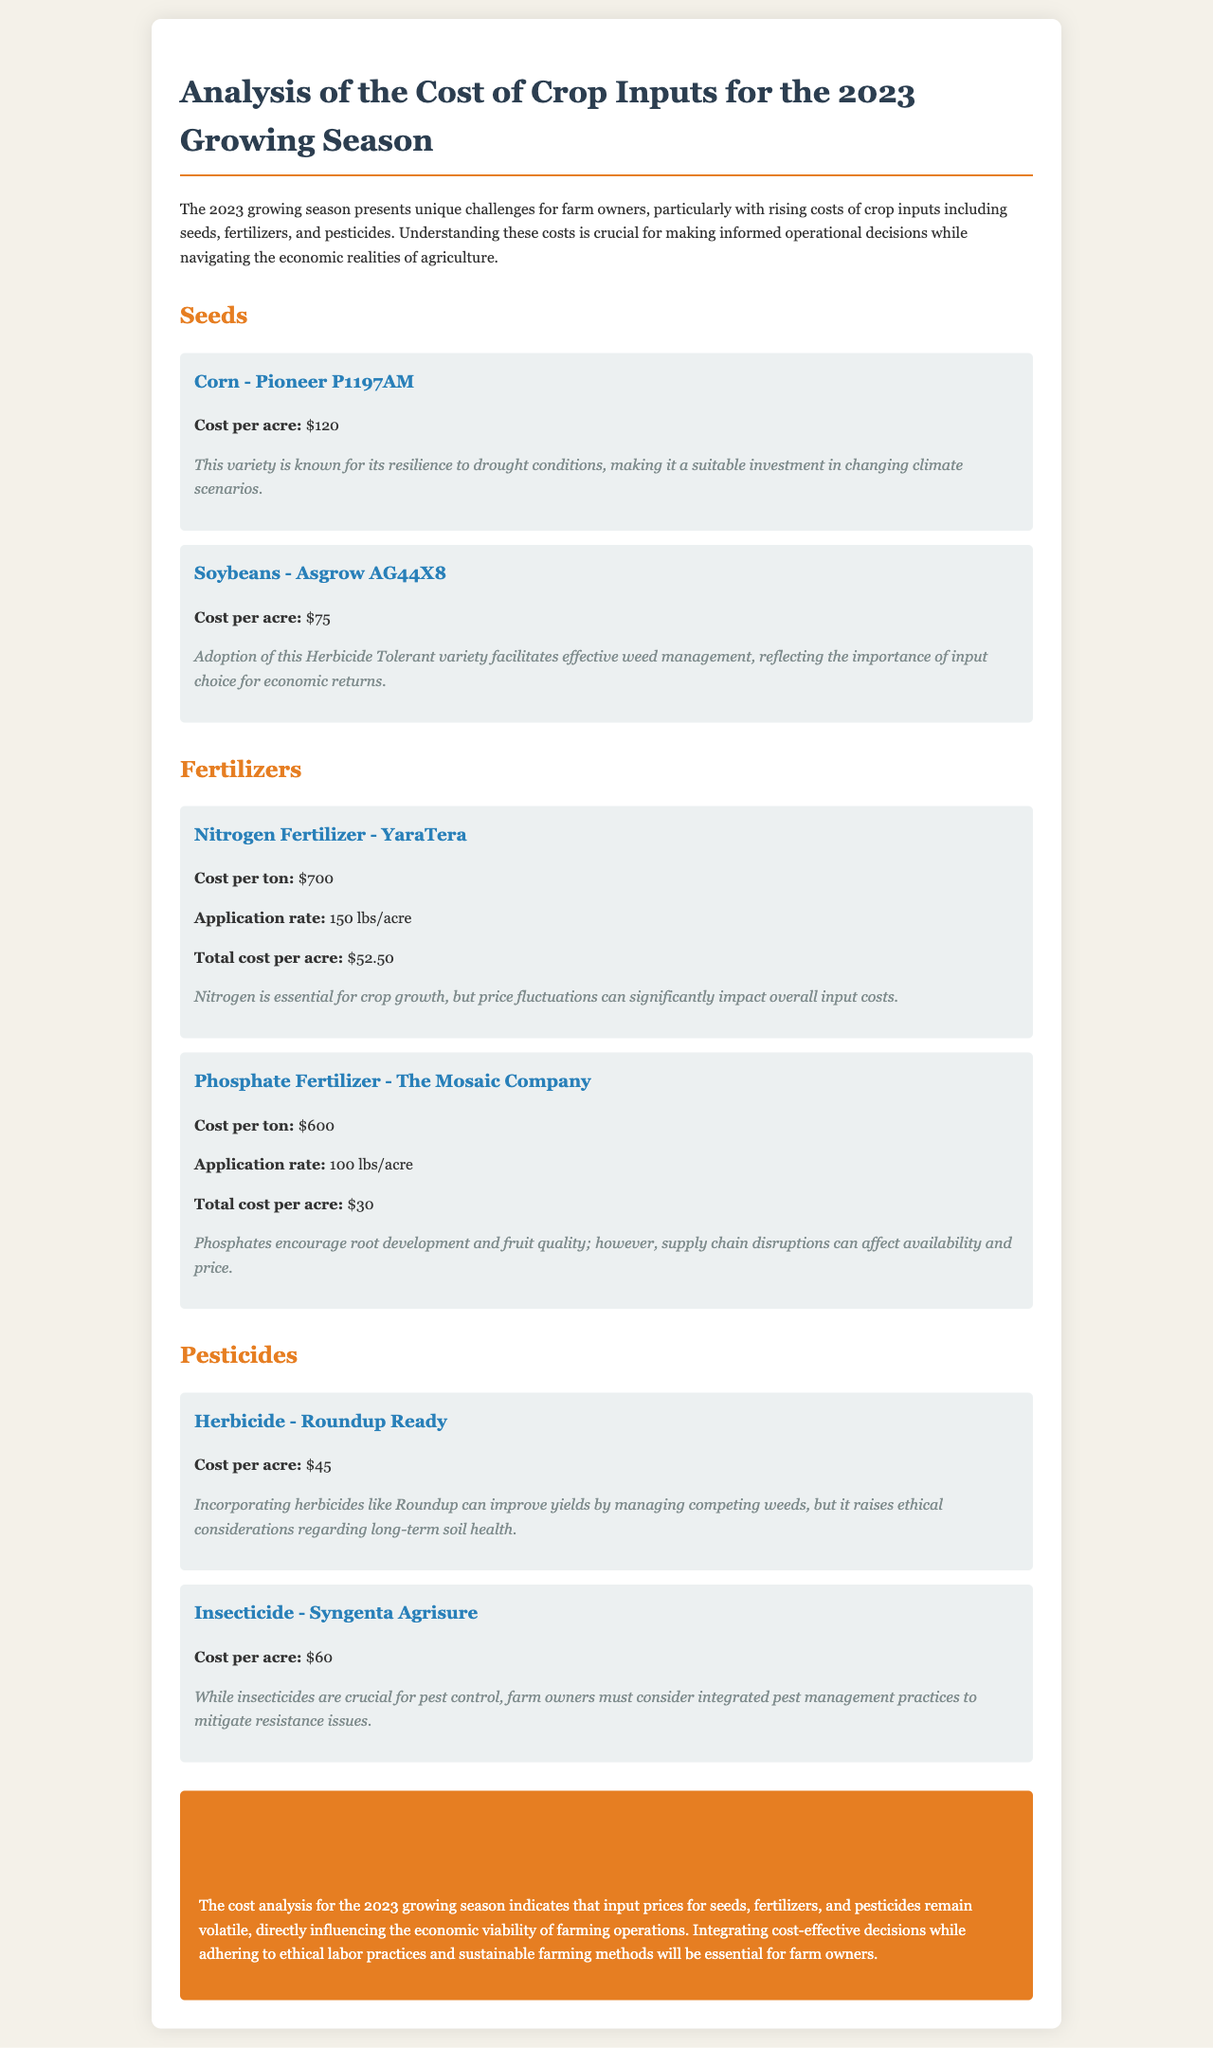What is the cost per acre for Corn - Pioneer P1197AM? The cost per acre for Corn - Pioneer P1197AM is stated in the document.
Answer: $120 What is the application rate for Nitrogen Fertilizer - YaraTera? The document provides specific application rates for fertilizers, including Nitrogen Fertilizer - YaraTera.
Answer: 150 lbs/acre What is the total cost per acre for Phosphate Fertilizer - The Mosaic Company? The document includes calculations for total costs per acre for different fertilizers, including Phosphate Fertilizer - The Mosaic Company.
Answer: $30 What ethical consideration is mentioned regarding the use of herbicides? The document discusses various ethical considerations about pesticide use, specifically herbicides.
Answer: Long-term soil health What is the conclusion regarding the cost analysis for farm owners? The conclusion summarizes the overall findings and implications for farm owners regarding input costs.
Answer: Volatile input prices What is the cost per acre for Soybeans - Asgrow AG44X8? The cost per acre is specifically listed for Soybeans - Asgrow AG44X8 in the seeds section.
Answer: $75 Which insecticide is mentioned with a cost per acre of $60? The document lists various pesticides along with their costs, including the specific insecticide at this price.
Answer: Syngenta Agrisure What role does Phosphate Fertilizer play for crops? The document mentions specific benefits of fertilizers, including those from Phosphate Fertilizer.
Answer: Root development and fruit quality 